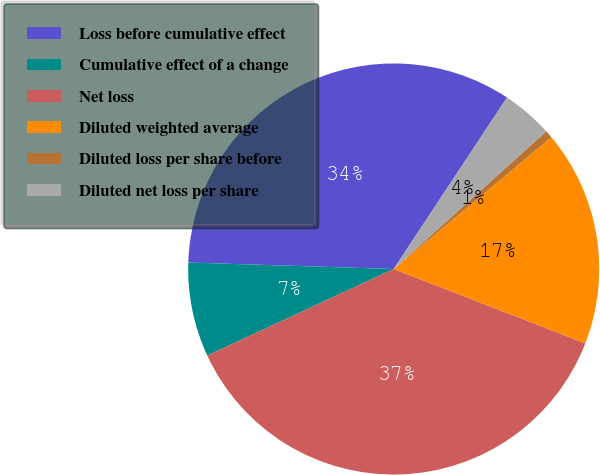Convert chart. <chart><loc_0><loc_0><loc_500><loc_500><pie_chart><fcel>Loss before cumulative effect<fcel>Cumulative effect of a change<fcel>Net loss<fcel>Diluted weighted average<fcel>Diluted loss per share before<fcel>Diluted net loss per share<nl><fcel>33.79%<fcel>7.42%<fcel>37.19%<fcel>16.97%<fcel>0.61%<fcel>4.02%<nl></chart> 